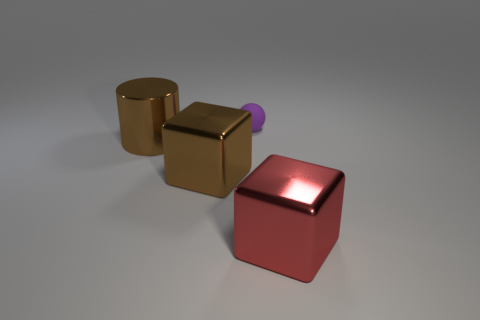Subtract all red cubes. How many cubes are left? 1 Subtract 1 blocks. How many blocks are left? 1 Subtract all gray balls. Subtract all cyan cylinders. How many balls are left? 1 Subtract all yellow cylinders. How many brown cubes are left? 1 Subtract all large red blocks. Subtract all brown things. How many objects are left? 1 Add 2 small spheres. How many small spheres are left? 3 Add 4 big red objects. How many big red objects exist? 5 Add 4 big red metal things. How many objects exist? 8 Subtract 1 red blocks. How many objects are left? 3 